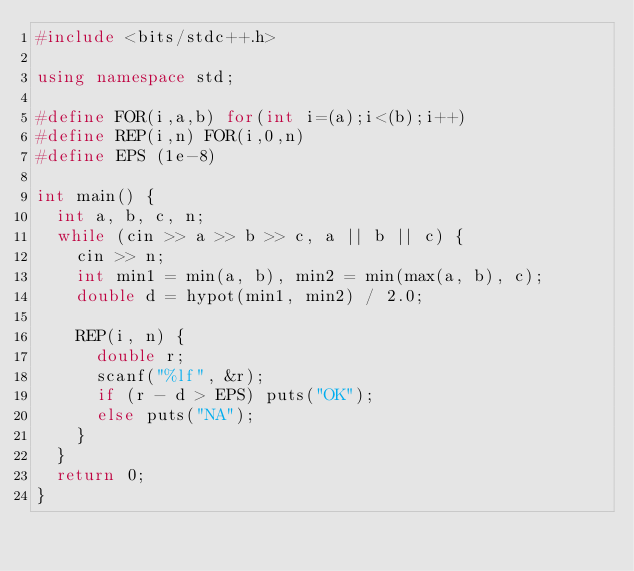Convert code to text. <code><loc_0><loc_0><loc_500><loc_500><_C++_>#include <bits/stdc++.h>

using namespace std;

#define FOR(i,a,b) for(int i=(a);i<(b);i++)
#define REP(i,n) FOR(i,0,n)
#define EPS (1e-8)

int main() {
	int a, b, c, n;
	while (cin >> a >> b >> c, a || b || c) {
		cin >> n;
		int min1 = min(a, b), min2 = min(max(a, b), c);
		double d = hypot(min1, min2) / 2.0;
		
		REP(i, n) {
			double r;
			scanf("%lf", &r);
			if (r - d > EPS) puts("OK");
			else puts("NA");
		}
	}
	return 0;
}</code> 